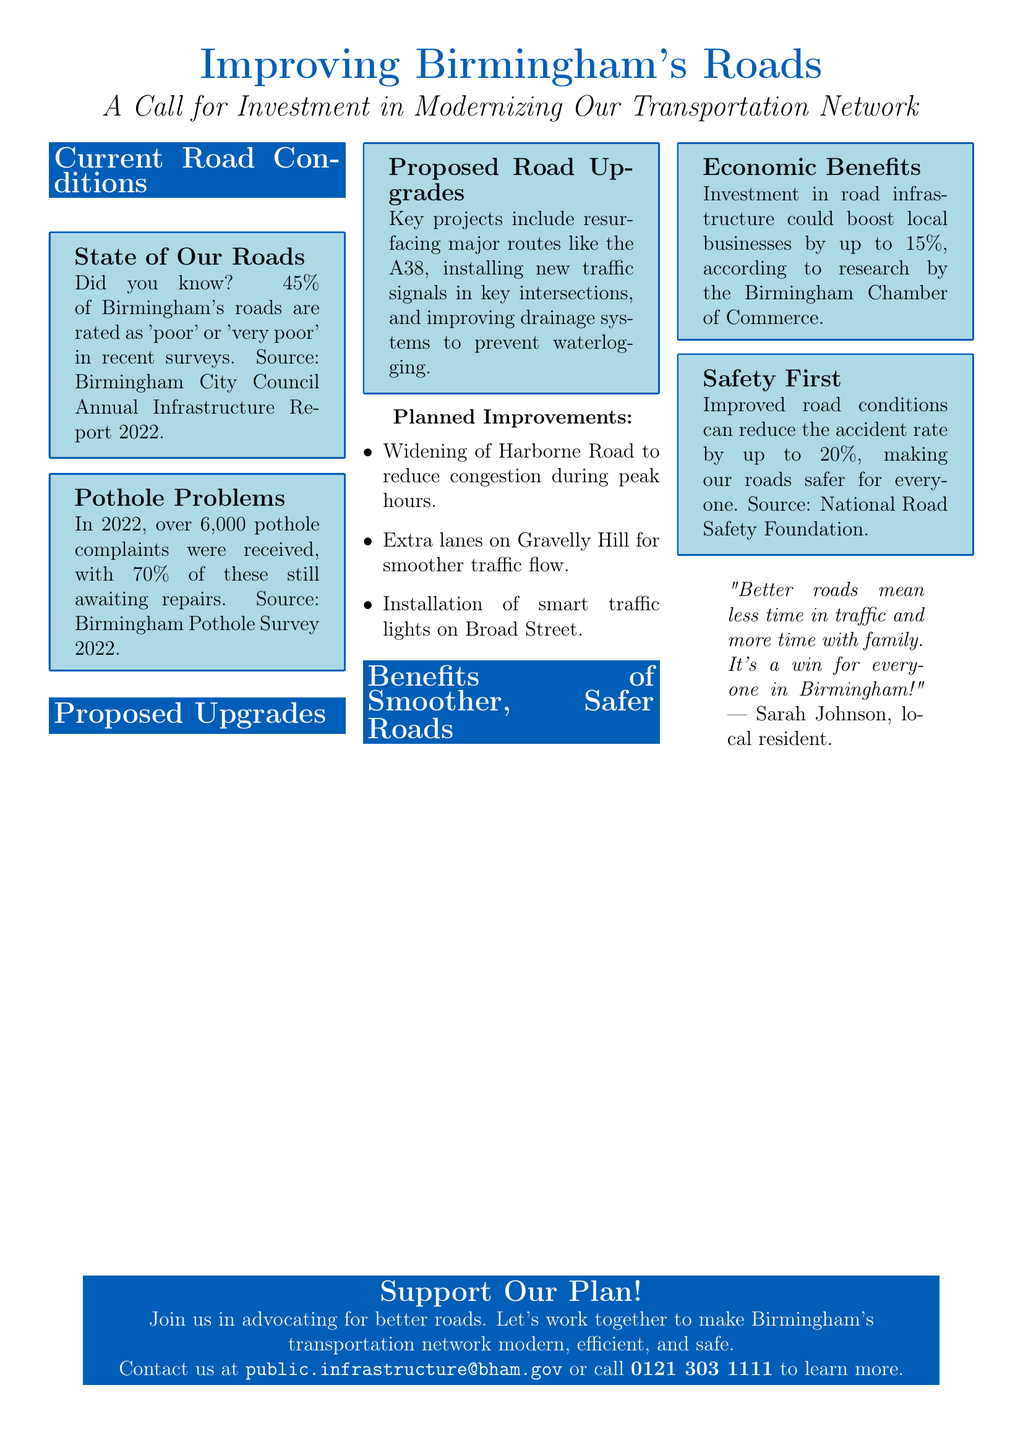What percentage of Birmingham's roads are rated as 'poor' or 'very poor'? The document states that 45% of Birmingham's roads fall into this category based on recent surveys.
Answer: 45% How many pothole complaints were received in 2022? According to the flyer, over 6,000 complaints were recorded regarding potholes.
Answer: 6,000 What is one of the key projects proposed for road upgrades? The document lists resurfacing major routes like the A38 as a key project for upgrades.
Answer: Resurfacing major routes like the A38 What potential boost to local businesses is mentioned regarding investment in road infrastructure? The flyer states that investment could boost local businesses by up to 15%.
Answer: 15% How much can accident rates potentially be reduced with improved road conditions? The document mentions that improved conditions can reduce the accident rate by up to 20%.
Answer: 20% What contact method is provided for additional information? The flyer includes an email address for inquiries about public infrastructure investment.
Answer: public.infrastructure@bham.gov What improvement will be made on Harborne Road? The document states that Harborne Road will be widened to reduce congestion during peak hours.
Answer: Widening to reduce congestion What is the color scheme used in the document's infographics? The document uses light blue for the background of infographics and birmingham blue for the borders and text.
Answer: Light blue and birmingham blue Who is quoted in the document regarding better roads? Sarah Johnson, a local resident, is quoted in the flyer about the benefits of better roads.
Answer: Sarah Johnson 